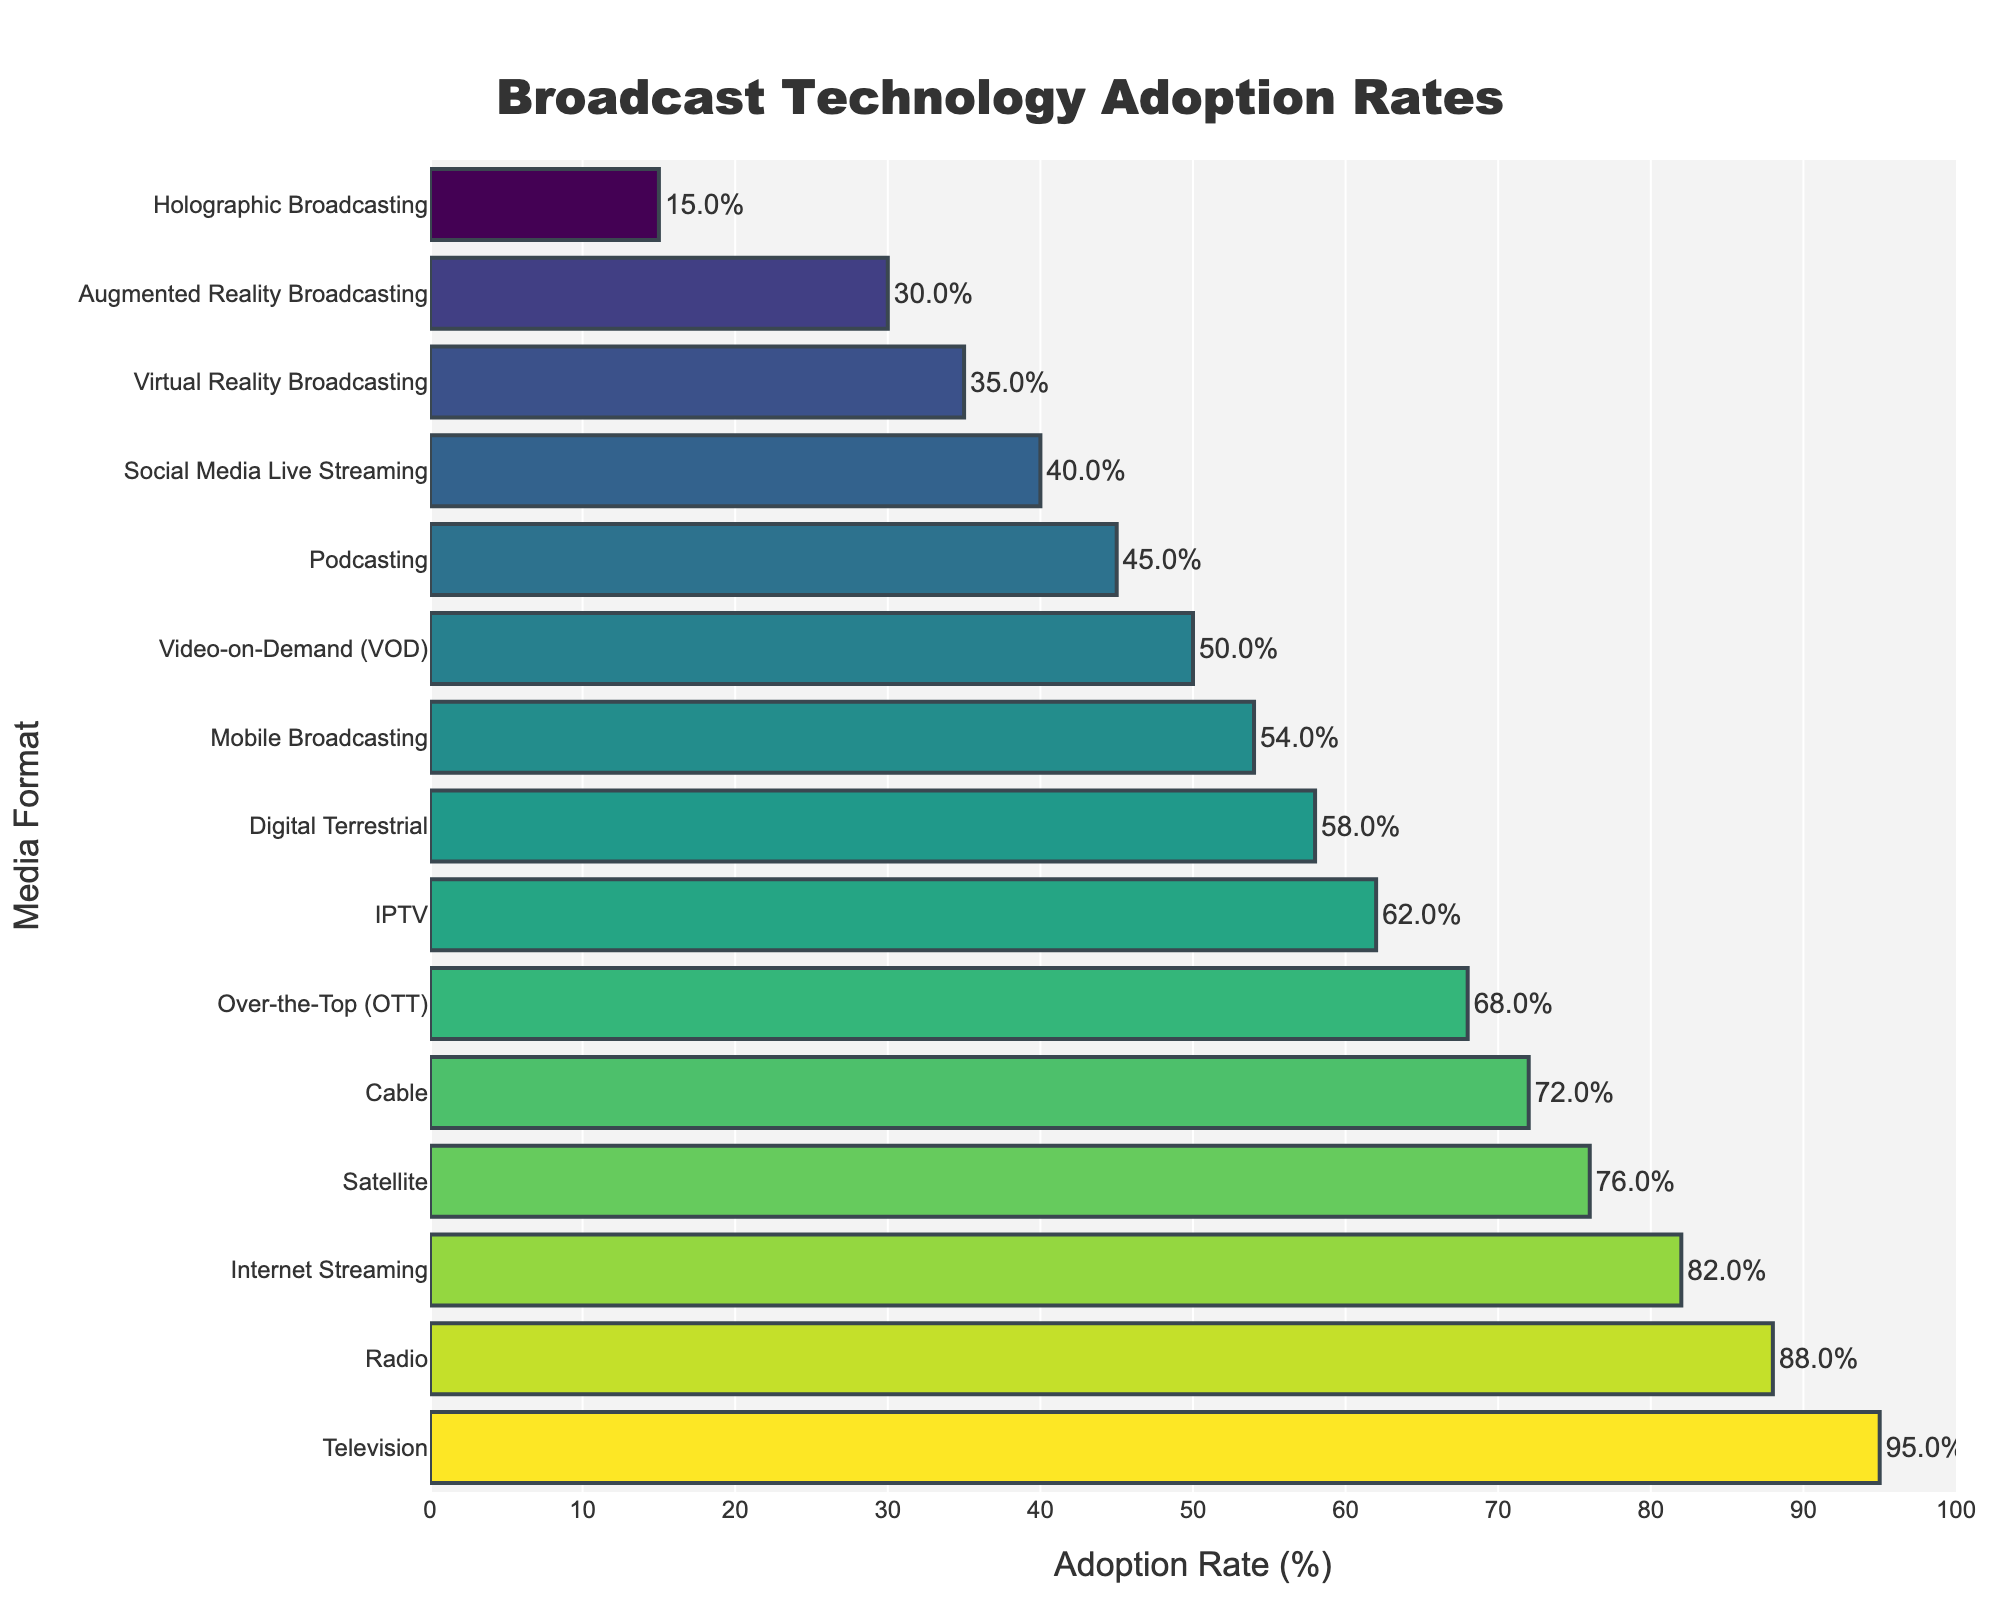What media format has the highest adoption rate? The media format with the highest adoption rate is the first bar in the sorted descending figure. The top bar corresponds to Television with an adoption rate of 95%.
Answer: Television Which media format has a lower adoption rate, IPTV or Digital Terrestrial? To find the media format with a lower adoption rate, compare the bars for IPTV and Digital Terrestrial. IPTV has an adoption rate of 62%, while Digital Terrestrial has an adoption rate of 58%. Therefore, Digital Terrestrial has a lower adoption rate.
Answer: Digital Terrestrial What is the adoption rate difference between the Internet Streaming and Video-on-Demand (VOD)? Look at the adoption rates for Internet Streaming and VOD. Internet Streaming has an adoption rate of 82%, and VOD has an adoption rate of 50%. Subtract the lower value from the higher one: 82% - 50% = 32%.
Answer: 32% Which format has more adoption, Mobile Broadcasting or Podcasting, and by how much? Compare the adoption rates for Mobile Broadcasting (54%) and Podcasting (45%), then calculate the difference: 54% - 45% = 9%. Mobile Broadcasting has more adoption by 9%.
Answer: Mobile Broadcasting, 9% What's the average adoption rate of Cable, Over-the-Top (OTT), and IPTV? Add the adoption rates for Cable (72%), OTT (68%), and IPTV (62%), then divide by the number of formats (3): (72 + 68 + 62) / 3 = 202 / 3 ≈ 67.33%.
Answer: 67.33% Which media formats have an adoption rate below 50%? Identify the media formats whose bars fall below the 50% mark. These formats are Podcasting (45%), Social Media Live Streaming (40%), Virtual Reality Broadcasting (35%), Augmented Reality Broadcasting (30%), and Holographic Broadcasting (15%).
Answer: Podcasting, Social Media Live Streaming, Virtual Reality Broadcasting, Augmented Reality Broadcasting, Holographic Broadcasting How much higher is the adoption rate of Satellite compared to Virtual Reality Broadcasting? Find the adoption rates for Satellite (76%) and Virtual Reality Broadcasting (35%), then calculate the difference: 76% - 35% = 41%. The adoption rate of Satellite is 41% higher.
Answer: 41% What is the total adoption rate for the top three media formats? Sum the adoption rates for the top three media formats: Television (95%), Radio (88%), and Internet Streaming (82%): 95 + 88 + 82 = 265%.
Answer: 265% Which format shows the steepest decline in adoption rate compared to its preceding format? To find the steepest decline, identify the segments where the difference between adjacent bars is the largest. The largest difference occurs between Augmented Reality Broadcasting (30%) and Holographic Broadcasting (15%), with a decline of 15%.
Answer: Augmented Reality Broadcasting to Holographic Broadcasting What's the range of adoption rates shown in the bar chart? The range is calculated by subtracting the lowest adoption rate from the highest. The highest adoption rate is Television (95%), and the lowest is Holographic Broadcasting (15%): 95% - 15% = 80%.
Answer: 80% 